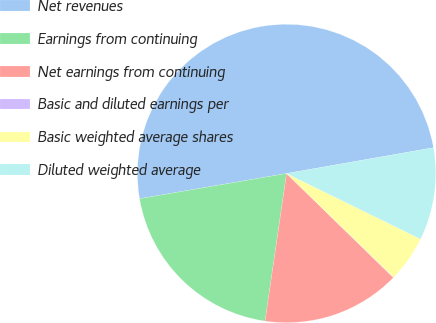<chart> <loc_0><loc_0><loc_500><loc_500><pie_chart><fcel>Net revenues<fcel>Earnings from continuing<fcel>Net earnings from continuing<fcel>Basic and diluted earnings per<fcel>Basic weighted average shares<fcel>Diluted weighted average<nl><fcel>49.93%<fcel>19.99%<fcel>15.0%<fcel>0.03%<fcel>5.02%<fcel>10.01%<nl></chart> 